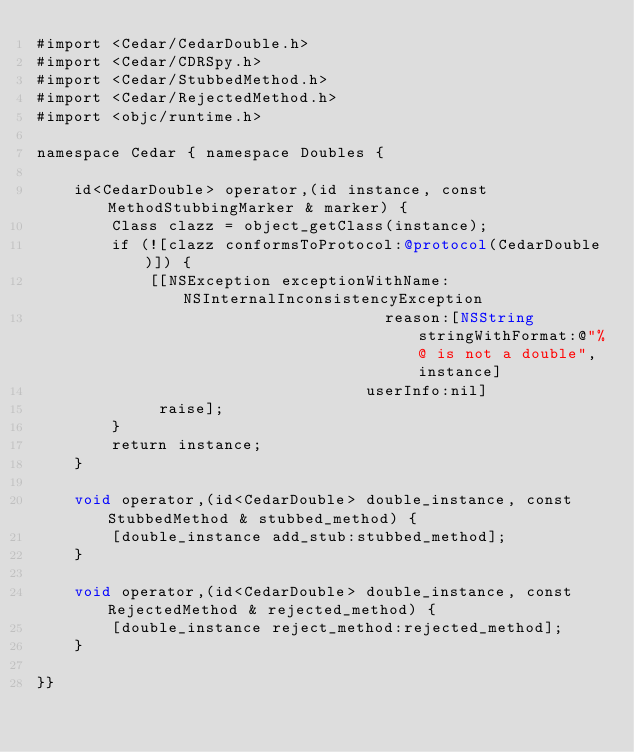<code> <loc_0><loc_0><loc_500><loc_500><_ObjectiveC_>#import <Cedar/CedarDouble.h>
#import <Cedar/CDRSpy.h>
#import <Cedar/StubbedMethod.h>
#import <Cedar/RejectedMethod.h>
#import <objc/runtime.h>

namespace Cedar { namespace Doubles {

    id<CedarDouble> operator,(id instance, const MethodStubbingMarker & marker) {
        Class clazz = object_getClass(instance);
        if (![clazz conformsToProtocol:@protocol(CedarDouble)]) {
            [[NSException exceptionWithName:NSInternalInconsistencyException
                                     reason:[NSString stringWithFormat:@"%@ is not a double", instance]
                                   userInfo:nil]
             raise];
        }
        return instance;
    }

    void operator,(id<CedarDouble> double_instance, const StubbedMethod & stubbed_method) {
        [double_instance add_stub:stubbed_method];
    }

    void operator,(id<CedarDouble> double_instance, const RejectedMethod & rejected_method) {
        [double_instance reject_method:rejected_method];
    }

}}
</code> 